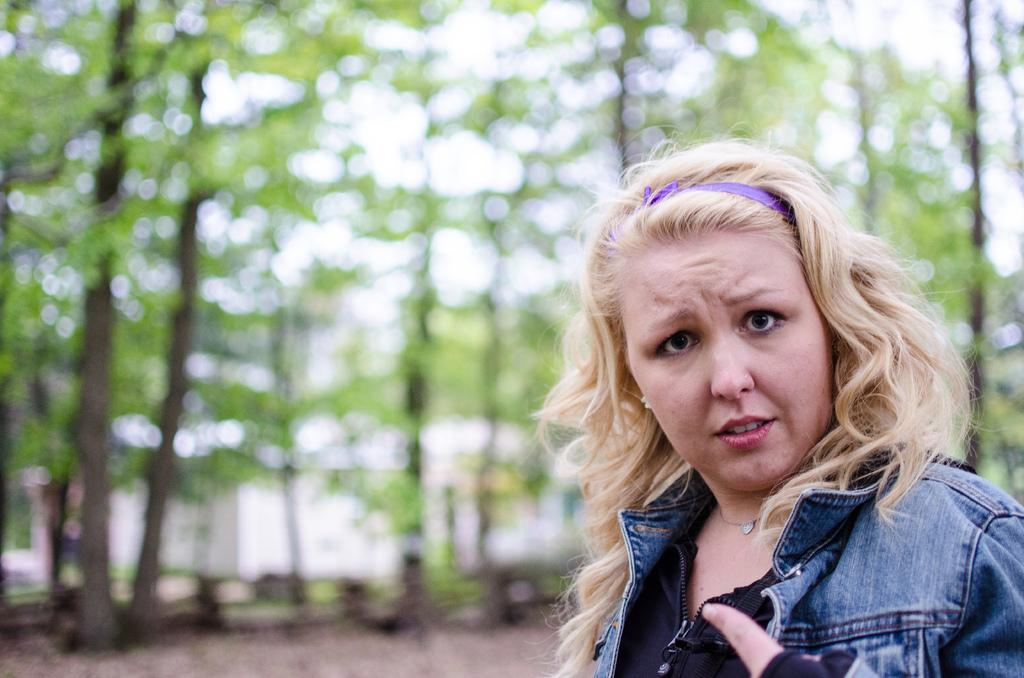Who is present in the image? There is a woman in the image. What is the woman wearing? The woman is wearing clothes, a neck chain, and earrings. What accessory is visible in the woman's hair? There is a hair belt in the image. What can be seen in the background of the image? There are trees and a blurred background in the image. What is the color of the sky in the image? The sky is white in the image. What is the weight of the self in the image? There is no reference to weight or self in the image. 